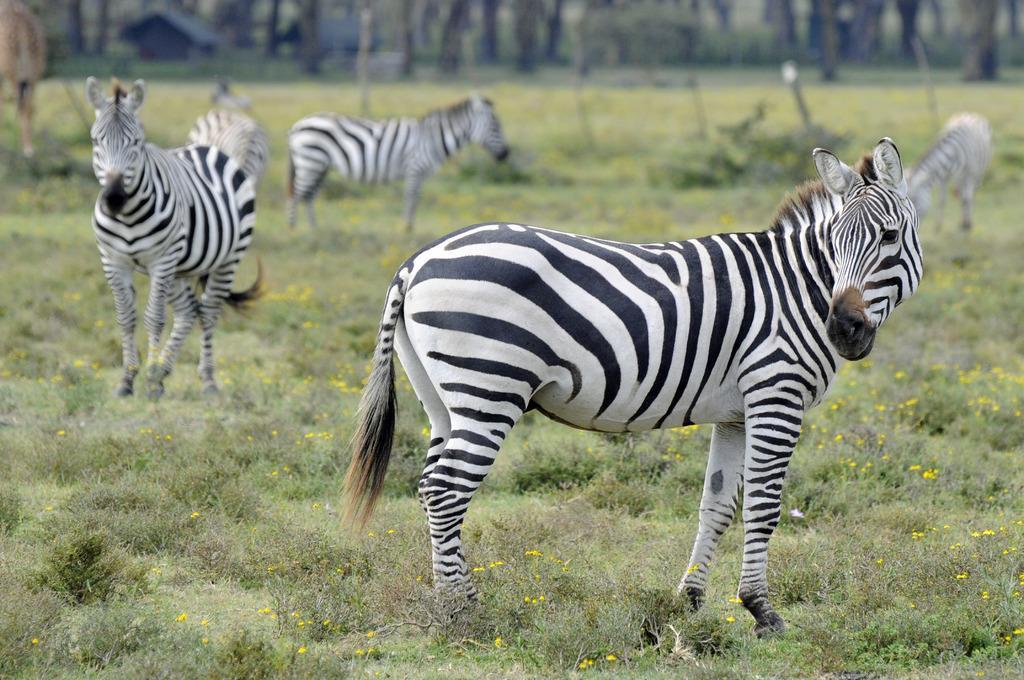Can you describe this image briefly? In this image on the ground there are many zebras. In the background there are buildings, trees. On the ground there are flower plants. 